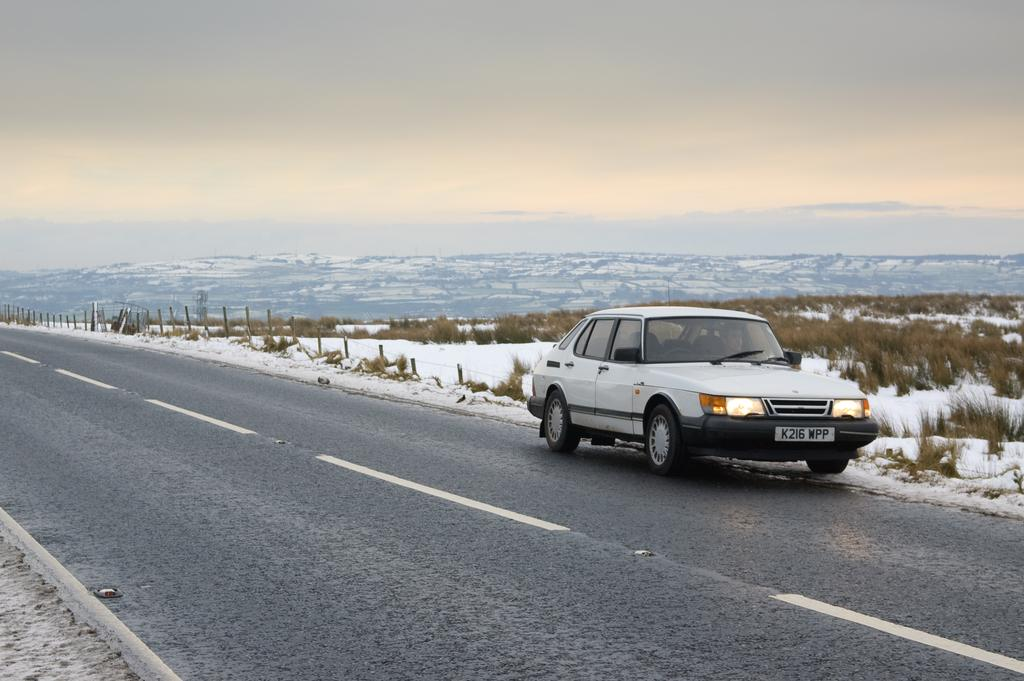What is located beside the road in the image? There is a vehicle beside the road in the image. What is the condition of the land behind the vehicle? The land behind the vehicle is covered with snow. What type of vegetation can be seen between the snow in the image? There is grass visible between the snow in the image. What direction is the uncle walking in the image? There is no uncle present in the image, so it is not possible to determine the direction in which they might be walking. 